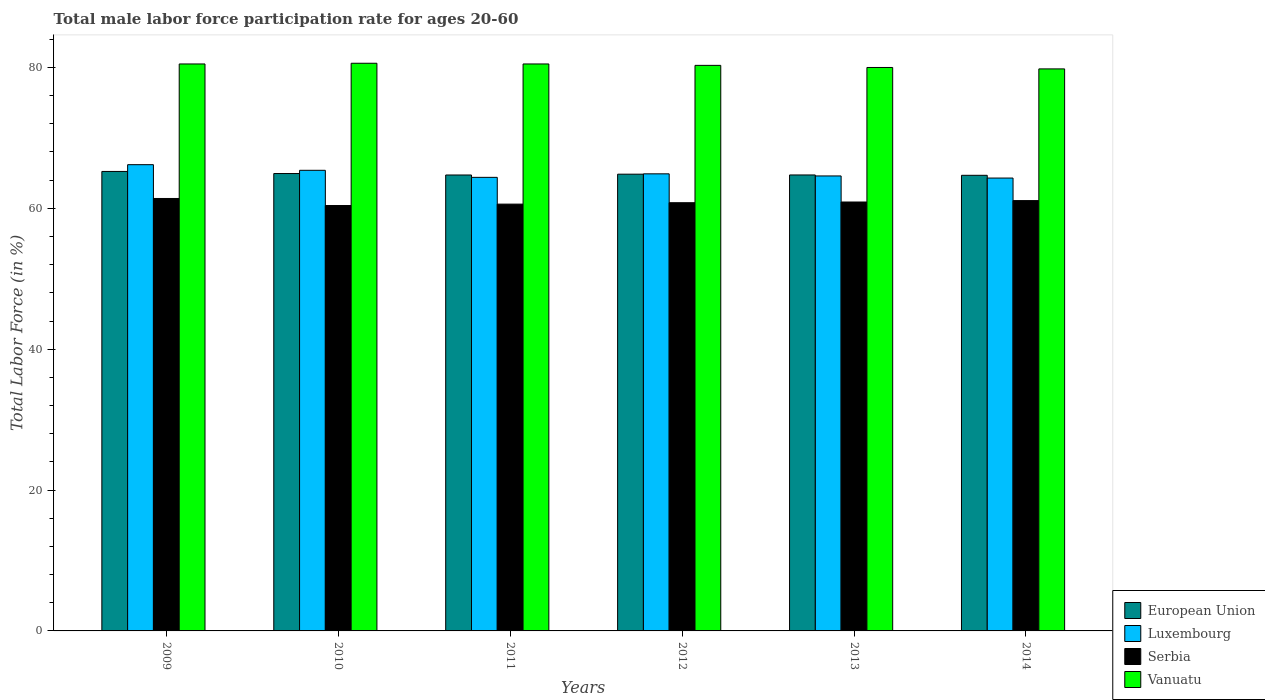How many different coloured bars are there?
Your answer should be very brief. 4. How many groups of bars are there?
Ensure brevity in your answer.  6. In how many cases, is the number of bars for a given year not equal to the number of legend labels?
Provide a succinct answer. 0. What is the male labor force participation rate in Serbia in 2011?
Provide a short and direct response. 60.6. Across all years, what is the maximum male labor force participation rate in Luxembourg?
Provide a short and direct response. 66.2. Across all years, what is the minimum male labor force participation rate in Luxembourg?
Give a very brief answer. 64.3. In which year was the male labor force participation rate in Vanuatu maximum?
Offer a terse response. 2010. In which year was the male labor force participation rate in Luxembourg minimum?
Your answer should be compact. 2014. What is the total male labor force participation rate in European Union in the graph?
Your response must be concise. 389.2. What is the difference between the male labor force participation rate in Vanuatu in 2011 and that in 2014?
Provide a short and direct response. 0.7. What is the difference between the male labor force participation rate in European Union in 2010 and the male labor force participation rate in Vanuatu in 2009?
Provide a succinct answer. -15.56. What is the average male labor force participation rate in Vanuatu per year?
Offer a terse response. 80.28. In the year 2011, what is the difference between the male labor force participation rate in European Union and male labor force participation rate in Luxembourg?
Give a very brief answer. 0.33. In how many years, is the male labor force participation rate in European Union greater than 8 %?
Keep it short and to the point. 6. What is the ratio of the male labor force participation rate in Vanuatu in 2009 to that in 2012?
Make the answer very short. 1. Is the male labor force participation rate in Luxembourg in 2011 less than that in 2013?
Your response must be concise. Yes. Is the difference between the male labor force participation rate in European Union in 2009 and 2013 greater than the difference between the male labor force participation rate in Luxembourg in 2009 and 2013?
Offer a very short reply. No. What is the difference between the highest and the second highest male labor force participation rate in Vanuatu?
Make the answer very short. 0.1. What is the difference between the highest and the lowest male labor force participation rate in Luxembourg?
Your answer should be very brief. 1.9. What does the 4th bar from the left in 2010 represents?
Ensure brevity in your answer.  Vanuatu. What does the 1st bar from the right in 2011 represents?
Your response must be concise. Vanuatu. How many bars are there?
Ensure brevity in your answer.  24. Are all the bars in the graph horizontal?
Ensure brevity in your answer.  No. How many years are there in the graph?
Provide a succinct answer. 6. How many legend labels are there?
Your response must be concise. 4. How are the legend labels stacked?
Provide a succinct answer. Vertical. What is the title of the graph?
Your response must be concise. Total male labor force participation rate for ages 20-60. Does "Sub-Saharan Africa (developing only)" appear as one of the legend labels in the graph?
Keep it short and to the point. No. What is the label or title of the X-axis?
Offer a very short reply. Years. What is the label or title of the Y-axis?
Offer a terse response. Total Labor Force (in %). What is the Total Labor Force (in %) in European Union in 2009?
Ensure brevity in your answer.  65.24. What is the Total Labor Force (in %) in Luxembourg in 2009?
Give a very brief answer. 66.2. What is the Total Labor Force (in %) in Serbia in 2009?
Your response must be concise. 61.4. What is the Total Labor Force (in %) in Vanuatu in 2009?
Ensure brevity in your answer.  80.5. What is the Total Labor Force (in %) of European Union in 2010?
Offer a very short reply. 64.94. What is the Total Labor Force (in %) of Luxembourg in 2010?
Provide a short and direct response. 65.4. What is the Total Labor Force (in %) in Serbia in 2010?
Provide a short and direct response. 60.4. What is the Total Labor Force (in %) in Vanuatu in 2010?
Your response must be concise. 80.6. What is the Total Labor Force (in %) in European Union in 2011?
Provide a succinct answer. 64.73. What is the Total Labor Force (in %) of Luxembourg in 2011?
Keep it short and to the point. 64.4. What is the Total Labor Force (in %) in Serbia in 2011?
Keep it short and to the point. 60.6. What is the Total Labor Force (in %) of Vanuatu in 2011?
Make the answer very short. 80.5. What is the Total Labor Force (in %) of European Union in 2012?
Your answer should be very brief. 64.85. What is the Total Labor Force (in %) of Luxembourg in 2012?
Give a very brief answer. 64.9. What is the Total Labor Force (in %) of Serbia in 2012?
Make the answer very short. 60.8. What is the Total Labor Force (in %) of Vanuatu in 2012?
Offer a very short reply. 80.3. What is the Total Labor Force (in %) of European Union in 2013?
Keep it short and to the point. 64.74. What is the Total Labor Force (in %) in Luxembourg in 2013?
Keep it short and to the point. 64.6. What is the Total Labor Force (in %) of Serbia in 2013?
Make the answer very short. 60.9. What is the Total Labor Force (in %) in European Union in 2014?
Your response must be concise. 64.69. What is the Total Labor Force (in %) in Luxembourg in 2014?
Your answer should be very brief. 64.3. What is the Total Labor Force (in %) of Serbia in 2014?
Keep it short and to the point. 61.1. What is the Total Labor Force (in %) in Vanuatu in 2014?
Offer a very short reply. 79.8. Across all years, what is the maximum Total Labor Force (in %) in European Union?
Your answer should be compact. 65.24. Across all years, what is the maximum Total Labor Force (in %) in Luxembourg?
Your answer should be compact. 66.2. Across all years, what is the maximum Total Labor Force (in %) in Serbia?
Your answer should be very brief. 61.4. Across all years, what is the maximum Total Labor Force (in %) of Vanuatu?
Offer a terse response. 80.6. Across all years, what is the minimum Total Labor Force (in %) of European Union?
Provide a succinct answer. 64.69. Across all years, what is the minimum Total Labor Force (in %) in Luxembourg?
Make the answer very short. 64.3. Across all years, what is the minimum Total Labor Force (in %) of Serbia?
Make the answer very short. 60.4. Across all years, what is the minimum Total Labor Force (in %) of Vanuatu?
Ensure brevity in your answer.  79.8. What is the total Total Labor Force (in %) in European Union in the graph?
Offer a terse response. 389.2. What is the total Total Labor Force (in %) of Luxembourg in the graph?
Provide a short and direct response. 389.8. What is the total Total Labor Force (in %) of Serbia in the graph?
Provide a succinct answer. 365.2. What is the total Total Labor Force (in %) of Vanuatu in the graph?
Provide a short and direct response. 481.7. What is the difference between the Total Labor Force (in %) of European Union in 2009 and that in 2010?
Your answer should be very brief. 0.3. What is the difference between the Total Labor Force (in %) of Serbia in 2009 and that in 2010?
Ensure brevity in your answer.  1. What is the difference between the Total Labor Force (in %) in Vanuatu in 2009 and that in 2010?
Offer a terse response. -0.1. What is the difference between the Total Labor Force (in %) in European Union in 2009 and that in 2011?
Your answer should be very brief. 0.5. What is the difference between the Total Labor Force (in %) in Luxembourg in 2009 and that in 2011?
Offer a terse response. 1.8. What is the difference between the Total Labor Force (in %) in Serbia in 2009 and that in 2011?
Your answer should be very brief. 0.8. What is the difference between the Total Labor Force (in %) of Vanuatu in 2009 and that in 2011?
Your response must be concise. 0. What is the difference between the Total Labor Force (in %) of European Union in 2009 and that in 2012?
Your answer should be very brief. 0.39. What is the difference between the Total Labor Force (in %) in Serbia in 2009 and that in 2012?
Keep it short and to the point. 0.6. What is the difference between the Total Labor Force (in %) of European Union in 2009 and that in 2013?
Provide a short and direct response. 0.5. What is the difference between the Total Labor Force (in %) in Serbia in 2009 and that in 2013?
Provide a succinct answer. 0.5. What is the difference between the Total Labor Force (in %) of European Union in 2009 and that in 2014?
Make the answer very short. 0.55. What is the difference between the Total Labor Force (in %) of Vanuatu in 2009 and that in 2014?
Ensure brevity in your answer.  0.7. What is the difference between the Total Labor Force (in %) of European Union in 2010 and that in 2011?
Offer a terse response. 0.21. What is the difference between the Total Labor Force (in %) of European Union in 2010 and that in 2012?
Give a very brief answer. 0.09. What is the difference between the Total Labor Force (in %) of Luxembourg in 2010 and that in 2012?
Provide a short and direct response. 0.5. What is the difference between the Total Labor Force (in %) in Vanuatu in 2010 and that in 2012?
Provide a short and direct response. 0.3. What is the difference between the Total Labor Force (in %) of European Union in 2010 and that in 2013?
Your answer should be very brief. 0.2. What is the difference between the Total Labor Force (in %) of Luxembourg in 2010 and that in 2013?
Make the answer very short. 0.8. What is the difference between the Total Labor Force (in %) in Vanuatu in 2010 and that in 2013?
Provide a short and direct response. 0.6. What is the difference between the Total Labor Force (in %) of European Union in 2010 and that in 2014?
Ensure brevity in your answer.  0.25. What is the difference between the Total Labor Force (in %) of Luxembourg in 2010 and that in 2014?
Offer a very short reply. 1.1. What is the difference between the Total Labor Force (in %) in Vanuatu in 2010 and that in 2014?
Your answer should be very brief. 0.8. What is the difference between the Total Labor Force (in %) of European Union in 2011 and that in 2012?
Make the answer very short. -0.12. What is the difference between the Total Labor Force (in %) of Luxembourg in 2011 and that in 2012?
Offer a very short reply. -0.5. What is the difference between the Total Labor Force (in %) in Vanuatu in 2011 and that in 2012?
Provide a short and direct response. 0.2. What is the difference between the Total Labor Force (in %) in European Union in 2011 and that in 2013?
Offer a terse response. -0.01. What is the difference between the Total Labor Force (in %) in Serbia in 2011 and that in 2013?
Offer a terse response. -0.3. What is the difference between the Total Labor Force (in %) of Vanuatu in 2011 and that in 2013?
Provide a succinct answer. 0.5. What is the difference between the Total Labor Force (in %) in European Union in 2011 and that in 2014?
Keep it short and to the point. 0.04. What is the difference between the Total Labor Force (in %) of Luxembourg in 2011 and that in 2014?
Give a very brief answer. 0.1. What is the difference between the Total Labor Force (in %) in Serbia in 2011 and that in 2014?
Provide a short and direct response. -0.5. What is the difference between the Total Labor Force (in %) in European Union in 2012 and that in 2013?
Offer a terse response. 0.11. What is the difference between the Total Labor Force (in %) of Luxembourg in 2012 and that in 2013?
Offer a very short reply. 0.3. What is the difference between the Total Labor Force (in %) of Serbia in 2012 and that in 2013?
Provide a short and direct response. -0.1. What is the difference between the Total Labor Force (in %) of European Union in 2012 and that in 2014?
Keep it short and to the point. 0.16. What is the difference between the Total Labor Force (in %) of Serbia in 2012 and that in 2014?
Give a very brief answer. -0.3. What is the difference between the Total Labor Force (in %) of Vanuatu in 2012 and that in 2014?
Ensure brevity in your answer.  0.5. What is the difference between the Total Labor Force (in %) in European Union in 2013 and that in 2014?
Your answer should be compact. 0.05. What is the difference between the Total Labor Force (in %) of Serbia in 2013 and that in 2014?
Give a very brief answer. -0.2. What is the difference between the Total Labor Force (in %) in European Union in 2009 and the Total Labor Force (in %) in Luxembourg in 2010?
Your response must be concise. -0.16. What is the difference between the Total Labor Force (in %) of European Union in 2009 and the Total Labor Force (in %) of Serbia in 2010?
Your answer should be compact. 4.84. What is the difference between the Total Labor Force (in %) of European Union in 2009 and the Total Labor Force (in %) of Vanuatu in 2010?
Make the answer very short. -15.36. What is the difference between the Total Labor Force (in %) in Luxembourg in 2009 and the Total Labor Force (in %) in Vanuatu in 2010?
Keep it short and to the point. -14.4. What is the difference between the Total Labor Force (in %) of Serbia in 2009 and the Total Labor Force (in %) of Vanuatu in 2010?
Your answer should be very brief. -19.2. What is the difference between the Total Labor Force (in %) of European Union in 2009 and the Total Labor Force (in %) of Luxembourg in 2011?
Keep it short and to the point. 0.84. What is the difference between the Total Labor Force (in %) in European Union in 2009 and the Total Labor Force (in %) in Serbia in 2011?
Ensure brevity in your answer.  4.64. What is the difference between the Total Labor Force (in %) in European Union in 2009 and the Total Labor Force (in %) in Vanuatu in 2011?
Offer a very short reply. -15.26. What is the difference between the Total Labor Force (in %) in Luxembourg in 2009 and the Total Labor Force (in %) in Serbia in 2011?
Your response must be concise. 5.6. What is the difference between the Total Labor Force (in %) in Luxembourg in 2009 and the Total Labor Force (in %) in Vanuatu in 2011?
Your answer should be compact. -14.3. What is the difference between the Total Labor Force (in %) in Serbia in 2009 and the Total Labor Force (in %) in Vanuatu in 2011?
Provide a short and direct response. -19.1. What is the difference between the Total Labor Force (in %) of European Union in 2009 and the Total Labor Force (in %) of Luxembourg in 2012?
Offer a terse response. 0.34. What is the difference between the Total Labor Force (in %) in European Union in 2009 and the Total Labor Force (in %) in Serbia in 2012?
Offer a terse response. 4.44. What is the difference between the Total Labor Force (in %) of European Union in 2009 and the Total Labor Force (in %) of Vanuatu in 2012?
Ensure brevity in your answer.  -15.06. What is the difference between the Total Labor Force (in %) in Luxembourg in 2009 and the Total Labor Force (in %) in Serbia in 2012?
Give a very brief answer. 5.4. What is the difference between the Total Labor Force (in %) in Luxembourg in 2009 and the Total Labor Force (in %) in Vanuatu in 2012?
Your answer should be compact. -14.1. What is the difference between the Total Labor Force (in %) of Serbia in 2009 and the Total Labor Force (in %) of Vanuatu in 2012?
Provide a short and direct response. -18.9. What is the difference between the Total Labor Force (in %) of European Union in 2009 and the Total Labor Force (in %) of Luxembourg in 2013?
Provide a short and direct response. 0.64. What is the difference between the Total Labor Force (in %) of European Union in 2009 and the Total Labor Force (in %) of Serbia in 2013?
Provide a succinct answer. 4.34. What is the difference between the Total Labor Force (in %) in European Union in 2009 and the Total Labor Force (in %) in Vanuatu in 2013?
Offer a terse response. -14.76. What is the difference between the Total Labor Force (in %) of Luxembourg in 2009 and the Total Labor Force (in %) of Serbia in 2013?
Provide a short and direct response. 5.3. What is the difference between the Total Labor Force (in %) in Luxembourg in 2009 and the Total Labor Force (in %) in Vanuatu in 2013?
Your response must be concise. -13.8. What is the difference between the Total Labor Force (in %) in Serbia in 2009 and the Total Labor Force (in %) in Vanuatu in 2013?
Ensure brevity in your answer.  -18.6. What is the difference between the Total Labor Force (in %) of European Union in 2009 and the Total Labor Force (in %) of Luxembourg in 2014?
Ensure brevity in your answer.  0.94. What is the difference between the Total Labor Force (in %) in European Union in 2009 and the Total Labor Force (in %) in Serbia in 2014?
Ensure brevity in your answer.  4.14. What is the difference between the Total Labor Force (in %) in European Union in 2009 and the Total Labor Force (in %) in Vanuatu in 2014?
Make the answer very short. -14.56. What is the difference between the Total Labor Force (in %) of Luxembourg in 2009 and the Total Labor Force (in %) of Vanuatu in 2014?
Provide a succinct answer. -13.6. What is the difference between the Total Labor Force (in %) of Serbia in 2009 and the Total Labor Force (in %) of Vanuatu in 2014?
Your response must be concise. -18.4. What is the difference between the Total Labor Force (in %) in European Union in 2010 and the Total Labor Force (in %) in Luxembourg in 2011?
Keep it short and to the point. 0.54. What is the difference between the Total Labor Force (in %) in European Union in 2010 and the Total Labor Force (in %) in Serbia in 2011?
Give a very brief answer. 4.34. What is the difference between the Total Labor Force (in %) in European Union in 2010 and the Total Labor Force (in %) in Vanuatu in 2011?
Offer a very short reply. -15.56. What is the difference between the Total Labor Force (in %) in Luxembourg in 2010 and the Total Labor Force (in %) in Serbia in 2011?
Your answer should be compact. 4.8. What is the difference between the Total Labor Force (in %) in Luxembourg in 2010 and the Total Labor Force (in %) in Vanuatu in 2011?
Your response must be concise. -15.1. What is the difference between the Total Labor Force (in %) of Serbia in 2010 and the Total Labor Force (in %) of Vanuatu in 2011?
Provide a short and direct response. -20.1. What is the difference between the Total Labor Force (in %) of European Union in 2010 and the Total Labor Force (in %) of Luxembourg in 2012?
Your answer should be compact. 0.04. What is the difference between the Total Labor Force (in %) of European Union in 2010 and the Total Labor Force (in %) of Serbia in 2012?
Your answer should be compact. 4.14. What is the difference between the Total Labor Force (in %) in European Union in 2010 and the Total Labor Force (in %) in Vanuatu in 2012?
Keep it short and to the point. -15.36. What is the difference between the Total Labor Force (in %) in Luxembourg in 2010 and the Total Labor Force (in %) in Serbia in 2012?
Offer a very short reply. 4.6. What is the difference between the Total Labor Force (in %) in Luxembourg in 2010 and the Total Labor Force (in %) in Vanuatu in 2012?
Offer a very short reply. -14.9. What is the difference between the Total Labor Force (in %) in Serbia in 2010 and the Total Labor Force (in %) in Vanuatu in 2012?
Provide a short and direct response. -19.9. What is the difference between the Total Labor Force (in %) of European Union in 2010 and the Total Labor Force (in %) of Luxembourg in 2013?
Give a very brief answer. 0.34. What is the difference between the Total Labor Force (in %) of European Union in 2010 and the Total Labor Force (in %) of Serbia in 2013?
Provide a succinct answer. 4.04. What is the difference between the Total Labor Force (in %) in European Union in 2010 and the Total Labor Force (in %) in Vanuatu in 2013?
Your answer should be compact. -15.06. What is the difference between the Total Labor Force (in %) of Luxembourg in 2010 and the Total Labor Force (in %) of Vanuatu in 2013?
Offer a terse response. -14.6. What is the difference between the Total Labor Force (in %) of Serbia in 2010 and the Total Labor Force (in %) of Vanuatu in 2013?
Keep it short and to the point. -19.6. What is the difference between the Total Labor Force (in %) of European Union in 2010 and the Total Labor Force (in %) of Luxembourg in 2014?
Offer a terse response. 0.64. What is the difference between the Total Labor Force (in %) in European Union in 2010 and the Total Labor Force (in %) in Serbia in 2014?
Provide a succinct answer. 3.84. What is the difference between the Total Labor Force (in %) of European Union in 2010 and the Total Labor Force (in %) of Vanuatu in 2014?
Ensure brevity in your answer.  -14.86. What is the difference between the Total Labor Force (in %) of Luxembourg in 2010 and the Total Labor Force (in %) of Serbia in 2014?
Provide a short and direct response. 4.3. What is the difference between the Total Labor Force (in %) in Luxembourg in 2010 and the Total Labor Force (in %) in Vanuatu in 2014?
Provide a short and direct response. -14.4. What is the difference between the Total Labor Force (in %) in Serbia in 2010 and the Total Labor Force (in %) in Vanuatu in 2014?
Your response must be concise. -19.4. What is the difference between the Total Labor Force (in %) in European Union in 2011 and the Total Labor Force (in %) in Luxembourg in 2012?
Provide a succinct answer. -0.17. What is the difference between the Total Labor Force (in %) of European Union in 2011 and the Total Labor Force (in %) of Serbia in 2012?
Make the answer very short. 3.93. What is the difference between the Total Labor Force (in %) of European Union in 2011 and the Total Labor Force (in %) of Vanuatu in 2012?
Provide a short and direct response. -15.57. What is the difference between the Total Labor Force (in %) in Luxembourg in 2011 and the Total Labor Force (in %) in Vanuatu in 2012?
Your answer should be very brief. -15.9. What is the difference between the Total Labor Force (in %) in Serbia in 2011 and the Total Labor Force (in %) in Vanuatu in 2012?
Provide a succinct answer. -19.7. What is the difference between the Total Labor Force (in %) in European Union in 2011 and the Total Labor Force (in %) in Luxembourg in 2013?
Offer a very short reply. 0.13. What is the difference between the Total Labor Force (in %) of European Union in 2011 and the Total Labor Force (in %) of Serbia in 2013?
Your answer should be compact. 3.83. What is the difference between the Total Labor Force (in %) of European Union in 2011 and the Total Labor Force (in %) of Vanuatu in 2013?
Offer a very short reply. -15.27. What is the difference between the Total Labor Force (in %) of Luxembourg in 2011 and the Total Labor Force (in %) of Vanuatu in 2013?
Offer a very short reply. -15.6. What is the difference between the Total Labor Force (in %) in Serbia in 2011 and the Total Labor Force (in %) in Vanuatu in 2013?
Give a very brief answer. -19.4. What is the difference between the Total Labor Force (in %) of European Union in 2011 and the Total Labor Force (in %) of Luxembourg in 2014?
Offer a terse response. 0.43. What is the difference between the Total Labor Force (in %) of European Union in 2011 and the Total Labor Force (in %) of Serbia in 2014?
Provide a short and direct response. 3.63. What is the difference between the Total Labor Force (in %) of European Union in 2011 and the Total Labor Force (in %) of Vanuatu in 2014?
Ensure brevity in your answer.  -15.07. What is the difference between the Total Labor Force (in %) of Luxembourg in 2011 and the Total Labor Force (in %) of Serbia in 2014?
Offer a very short reply. 3.3. What is the difference between the Total Labor Force (in %) in Luxembourg in 2011 and the Total Labor Force (in %) in Vanuatu in 2014?
Your response must be concise. -15.4. What is the difference between the Total Labor Force (in %) of Serbia in 2011 and the Total Labor Force (in %) of Vanuatu in 2014?
Your response must be concise. -19.2. What is the difference between the Total Labor Force (in %) of European Union in 2012 and the Total Labor Force (in %) of Luxembourg in 2013?
Offer a terse response. 0.25. What is the difference between the Total Labor Force (in %) in European Union in 2012 and the Total Labor Force (in %) in Serbia in 2013?
Offer a very short reply. 3.95. What is the difference between the Total Labor Force (in %) in European Union in 2012 and the Total Labor Force (in %) in Vanuatu in 2013?
Offer a very short reply. -15.15. What is the difference between the Total Labor Force (in %) of Luxembourg in 2012 and the Total Labor Force (in %) of Serbia in 2013?
Make the answer very short. 4. What is the difference between the Total Labor Force (in %) in Luxembourg in 2012 and the Total Labor Force (in %) in Vanuatu in 2013?
Your answer should be compact. -15.1. What is the difference between the Total Labor Force (in %) of Serbia in 2012 and the Total Labor Force (in %) of Vanuatu in 2013?
Your response must be concise. -19.2. What is the difference between the Total Labor Force (in %) in European Union in 2012 and the Total Labor Force (in %) in Luxembourg in 2014?
Offer a very short reply. 0.55. What is the difference between the Total Labor Force (in %) of European Union in 2012 and the Total Labor Force (in %) of Serbia in 2014?
Make the answer very short. 3.75. What is the difference between the Total Labor Force (in %) of European Union in 2012 and the Total Labor Force (in %) of Vanuatu in 2014?
Your answer should be compact. -14.95. What is the difference between the Total Labor Force (in %) in Luxembourg in 2012 and the Total Labor Force (in %) in Serbia in 2014?
Keep it short and to the point. 3.8. What is the difference between the Total Labor Force (in %) of Luxembourg in 2012 and the Total Labor Force (in %) of Vanuatu in 2014?
Give a very brief answer. -14.9. What is the difference between the Total Labor Force (in %) of European Union in 2013 and the Total Labor Force (in %) of Luxembourg in 2014?
Ensure brevity in your answer.  0.44. What is the difference between the Total Labor Force (in %) of European Union in 2013 and the Total Labor Force (in %) of Serbia in 2014?
Offer a terse response. 3.64. What is the difference between the Total Labor Force (in %) of European Union in 2013 and the Total Labor Force (in %) of Vanuatu in 2014?
Provide a short and direct response. -15.06. What is the difference between the Total Labor Force (in %) in Luxembourg in 2013 and the Total Labor Force (in %) in Vanuatu in 2014?
Give a very brief answer. -15.2. What is the difference between the Total Labor Force (in %) in Serbia in 2013 and the Total Labor Force (in %) in Vanuatu in 2014?
Ensure brevity in your answer.  -18.9. What is the average Total Labor Force (in %) of European Union per year?
Your answer should be compact. 64.87. What is the average Total Labor Force (in %) of Luxembourg per year?
Provide a succinct answer. 64.97. What is the average Total Labor Force (in %) in Serbia per year?
Offer a terse response. 60.87. What is the average Total Labor Force (in %) in Vanuatu per year?
Make the answer very short. 80.28. In the year 2009, what is the difference between the Total Labor Force (in %) of European Union and Total Labor Force (in %) of Luxembourg?
Provide a short and direct response. -0.96. In the year 2009, what is the difference between the Total Labor Force (in %) of European Union and Total Labor Force (in %) of Serbia?
Provide a short and direct response. 3.84. In the year 2009, what is the difference between the Total Labor Force (in %) of European Union and Total Labor Force (in %) of Vanuatu?
Keep it short and to the point. -15.26. In the year 2009, what is the difference between the Total Labor Force (in %) in Luxembourg and Total Labor Force (in %) in Serbia?
Provide a short and direct response. 4.8. In the year 2009, what is the difference between the Total Labor Force (in %) in Luxembourg and Total Labor Force (in %) in Vanuatu?
Provide a short and direct response. -14.3. In the year 2009, what is the difference between the Total Labor Force (in %) of Serbia and Total Labor Force (in %) of Vanuatu?
Give a very brief answer. -19.1. In the year 2010, what is the difference between the Total Labor Force (in %) of European Union and Total Labor Force (in %) of Luxembourg?
Offer a terse response. -0.46. In the year 2010, what is the difference between the Total Labor Force (in %) in European Union and Total Labor Force (in %) in Serbia?
Ensure brevity in your answer.  4.54. In the year 2010, what is the difference between the Total Labor Force (in %) in European Union and Total Labor Force (in %) in Vanuatu?
Your answer should be very brief. -15.66. In the year 2010, what is the difference between the Total Labor Force (in %) of Luxembourg and Total Labor Force (in %) of Vanuatu?
Your answer should be compact. -15.2. In the year 2010, what is the difference between the Total Labor Force (in %) of Serbia and Total Labor Force (in %) of Vanuatu?
Your answer should be very brief. -20.2. In the year 2011, what is the difference between the Total Labor Force (in %) in European Union and Total Labor Force (in %) in Luxembourg?
Offer a terse response. 0.33. In the year 2011, what is the difference between the Total Labor Force (in %) in European Union and Total Labor Force (in %) in Serbia?
Give a very brief answer. 4.13. In the year 2011, what is the difference between the Total Labor Force (in %) of European Union and Total Labor Force (in %) of Vanuatu?
Offer a very short reply. -15.77. In the year 2011, what is the difference between the Total Labor Force (in %) of Luxembourg and Total Labor Force (in %) of Vanuatu?
Keep it short and to the point. -16.1. In the year 2011, what is the difference between the Total Labor Force (in %) of Serbia and Total Labor Force (in %) of Vanuatu?
Provide a succinct answer. -19.9. In the year 2012, what is the difference between the Total Labor Force (in %) of European Union and Total Labor Force (in %) of Luxembourg?
Your answer should be compact. -0.05. In the year 2012, what is the difference between the Total Labor Force (in %) in European Union and Total Labor Force (in %) in Serbia?
Your response must be concise. 4.05. In the year 2012, what is the difference between the Total Labor Force (in %) in European Union and Total Labor Force (in %) in Vanuatu?
Your answer should be very brief. -15.45. In the year 2012, what is the difference between the Total Labor Force (in %) in Luxembourg and Total Labor Force (in %) in Vanuatu?
Ensure brevity in your answer.  -15.4. In the year 2012, what is the difference between the Total Labor Force (in %) in Serbia and Total Labor Force (in %) in Vanuatu?
Keep it short and to the point. -19.5. In the year 2013, what is the difference between the Total Labor Force (in %) of European Union and Total Labor Force (in %) of Luxembourg?
Your response must be concise. 0.14. In the year 2013, what is the difference between the Total Labor Force (in %) of European Union and Total Labor Force (in %) of Serbia?
Provide a short and direct response. 3.84. In the year 2013, what is the difference between the Total Labor Force (in %) in European Union and Total Labor Force (in %) in Vanuatu?
Your answer should be very brief. -15.26. In the year 2013, what is the difference between the Total Labor Force (in %) of Luxembourg and Total Labor Force (in %) of Vanuatu?
Offer a very short reply. -15.4. In the year 2013, what is the difference between the Total Labor Force (in %) of Serbia and Total Labor Force (in %) of Vanuatu?
Provide a succinct answer. -19.1. In the year 2014, what is the difference between the Total Labor Force (in %) of European Union and Total Labor Force (in %) of Luxembourg?
Keep it short and to the point. 0.39. In the year 2014, what is the difference between the Total Labor Force (in %) in European Union and Total Labor Force (in %) in Serbia?
Your answer should be compact. 3.59. In the year 2014, what is the difference between the Total Labor Force (in %) of European Union and Total Labor Force (in %) of Vanuatu?
Your response must be concise. -15.11. In the year 2014, what is the difference between the Total Labor Force (in %) in Luxembourg and Total Labor Force (in %) in Serbia?
Offer a terse response. 3.2. In the year 2014, what is the difference between the Total Labor Force (in %) in Luxembourg and Total Labor Force (in %) in Vanuatu?
Your answer should be compact. -15.5. In the year 2014, what is the difference between the Total Labor Force (in %) in Serbia and Total Labor Force (in %) in Vanuatu?
Provide a succinct answer. -18.7. What is the ratio of the Total Labor Force (in %) in European Union in 2009 to that in 2010?
Provide a short and direct response. 1. What is the ratio of the Total Labor Force (in %) of Luxembourg in 2009 to that in 2010?
Your response must be concise. 1.01. What is the ratio of the Total Labor Force (in %) of Serbia in 2009 to that in 2010?
Offer a very short reply. 1.02. What is the ratio of the Total Labor Force (in %) of Vanuatu in 2009 to that in 2010?
Your answer should be compact. 1. What is the ratio of the Total Labor Force (in %) of European Union in 2009 to that in 2011?
Offer a very short reply. 1.01. What is the ratio of the Total Labor Force (in %) of Luxembourg in 2009 to that in 2011?
Give a very brief answer. 1.03. What is the ratio of the Total Labor Force (in %) of Serbia in 2009 to that in 2011?
Make the answer very short. 1.01. What is the ratio of the Total Labor Force (in %) of European Union in 2009 to that in 2012?
Provide a succinct answer. 1.01. What is the ratio of the Total Labor Force (in %) of Serbia in 2009 to that in 2012?
Offer a very short reply. 1.01. What is the ratio of the Total Labor Force (in %) of Vanuatu in 2009 to that in 2012?
Make the answer very short. 1. What is the ratio of the Total Labor Force (in %) of European Union in 2009 to that in 2013?
Your response must be concise. 1.01. What is the ratio of the Total Labor Force (in %) in Luxembourg in 2009 to that in 2013?
Ensure brevity in your answer.  1.02. What is the ratio of the Total Labor Force (in %) in Serbia in 2009 to that in 2013?
Your answer should be compact. 1.01. What is the ratio of the Total Labor Force (in %) of European Union in 2009 to that in 2014?
Offer a terse response. 1.01. What is the ratio of the Total Labor Force (in %) in Luxembourg in 2009 to that in 2014?
Offer a very short reply. 1.03. What is the ratio of the Total Labor Force (in %) of Serbia in 2009 to that in 2014?
Provide a short and direct response. 1. What is the ratio of the Total Labor Force (in %) of Vanuatu in 2009 to that in 2014?
Keep it short and to the point. 1.01. What is the ratio of the Total Labor Force (in %) in European Union in 2010 to that in 2011?
Provide a short and direct response. 1. What is the ratio of the Total Labor Force (in %) of Luxembourg in 2010 to that in 2011?
Your response must be concise. 1.02. What is the ratio of the Total Labor Force (in %) in Vanuatu in 2010 to that in 2011?
Offer a very short reply. 1. What is the ratio of the Total Labor Force (in %) of European Union in 2010 to that in 2012?
Provide a short and direct response. 1. What is the ratio of the Total Labor Force (in %) in Luxembourg in 2010 to that in 2012?
Your answer should be compact. 1.01. What is the ratio of the Total Labor Force (in %) in Serbia in 2010 to that in 2012?
Offer a terse response. 0.99. What is the ratio of the Total Labor Force (in %) in Vanuatu in 2010 to that in 2012?
Provide a short and direct response. 1. What is the ratio of the Total Labor Force (in %) of European Union in 2010 to that in 2013?
Provide a short and direct response. 1. What is the ratio of the Total Labor Force (in %) of Luxembourg in 2010 to that in 2013?
Ensure brevity in your answer.  1.01. What is the ratio of the Total Labor Force (in %) of Serbia in 2010 to that in 2013?
Make the answer very short. 0.99. What is the ratio of the Total Labor Force (in %) of Vanuatu in 2010 to that in 2013?
Your answer should be compact. 1.01. What is the ratio of the Total Labor Force (in %) in European Union in 2010 to that in 2014?
Give a very brief answer. 1. What is the ratio of the Total Labor Force (in %) of Luxembourg in 2010 to that in 2014?
Provide a succinct answer. 1.02. What is the ratio of the Total Labor Force (in %) in Serbia in 2010 to that in 2014?
Your response must be concise. 0.99. What is the ratio of the Total Labor Force (in %) of European Union in 2011 to that in 2012?
Provide a short and direct response. 1. What is the ratio of the Total Labor Force (in %) of Luxembourg in 2011 to that in 2012?
Provide a succinct answer. 0.99. What is the ratio of the Total Labor Force (in %) in Serbia in 2011 to that in 2013?
Give a very brief answer. 1. What is the ratio of the Total Labor Force (in %) of Vanuatu in 2011 to that in 2013?
Keep it short and to the point. 1.01. What is the ratio of the Total Labor Force (in %) of Luxembourg in 2011 to that in 2014?
Provide a short and direct response. 1. What is the ratio of the Total Labor Force (in %) in Vanuatu in 2011 to that in 2014?
Provide a short and direct response. 1.01. What is the ratio of the Total Labor Force (in %) of Vanuatu in 2012 to that in 2013?
Offer a very short reply. 1. What is the ratio of the Total Labor Force (in %) in European Union in 2012 to that in 2014?
Your answer should be compact. 1. What is the ratio of the Total Labor Force (in %) of Luxembourg in 2012 to that in 2014?
Provide a succinct answer. 1.01. What is the ratio of the Total Labor Force (in %) in Serbia in 2012 to that in 2014?
Offer a very short reply. 1. What is the ratio of the Total Labor Force (in %) of Vanuatu in 2012 to that in 2014?
Provide a short and direct response. 1.01. What is the ratio of the Total Labor Force (in %) of European Union in 2013 to that in 2014?
Your response must be concise. 1. What is the ratio of the Total Labor Force (in %) of Serbia in 2013 to that in 2014?
Your response must be concise. 1. What is the difference between the highest and the second highest Total Labor Force (in %) in European Union?
Offer a terse response. 0.3. What is the difference between the highest and the second highest Total Labor Force (in %) in Luxembourg?
Your response must be concise. 0.8. What is the difference between the highest and the second highest Total Labor Force (in %) in Serbia?
Your answer should be very brief. 0.3. What is the difference between the highest and the second highest Total Labor Force (in %) in Vanuatu?
Ensure brevity in your answer.  0.1. What is the difference between the highest and the lowest Total Labor Force (in %) in European Union?
Keep it short and to the point. 0.55. What is the difference between the highest and the lowest Total Labor Force (in %) of Serbia?
Offer a very short reply. 1. 